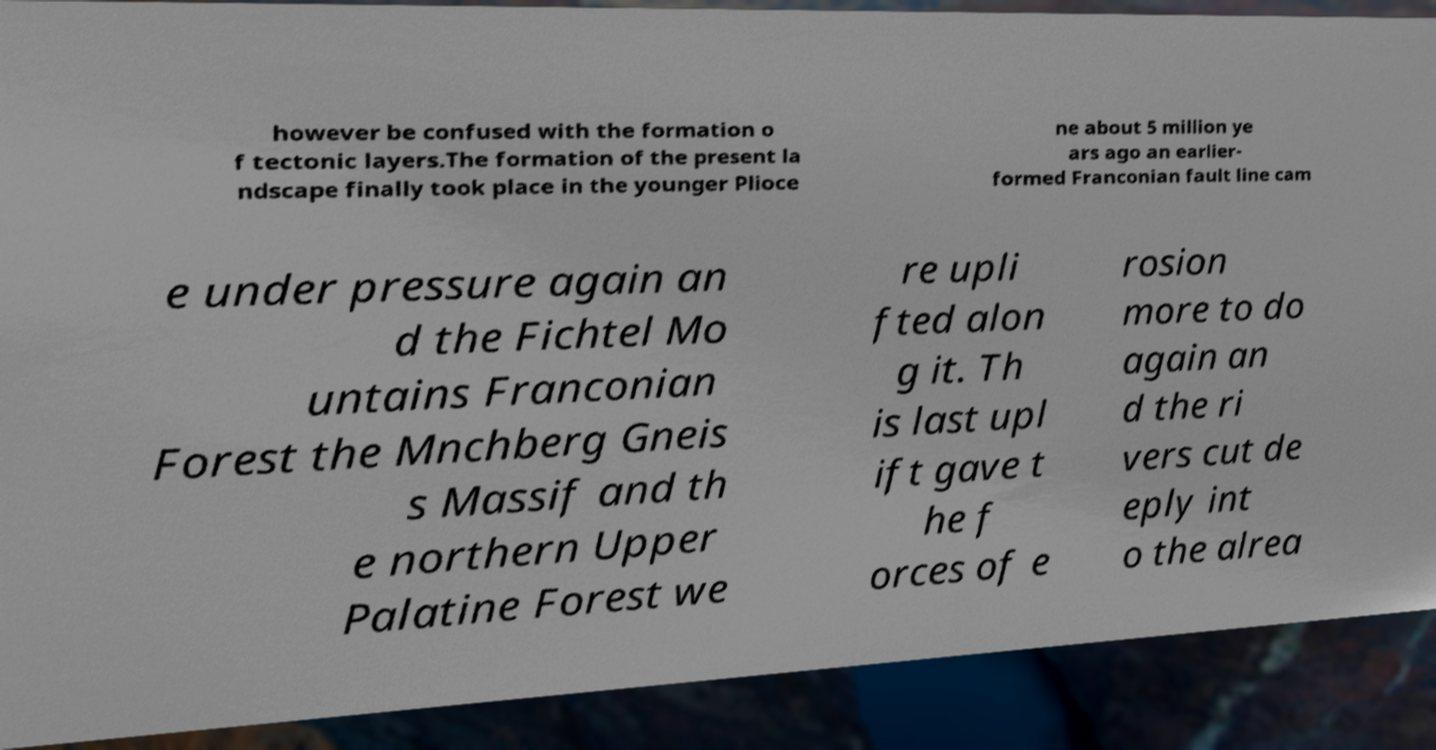Please identify and transcribe the text found in this image. however be confused with the formation o f tectonic layers.The formation of the present la ndscape finally took place in the younger Plioce ne about 5 million ye ars ago an earlier- formed Franconian fault line cam e under pressure again an d the Fichtel Mo untains Franconian Forest the Mnchberg Gneis s Massif and th e northern Upper Palatine Forest we re upli fted alon g it. Th is last upl ift gave t he f orces of e rosion more to do again an d the ri vers cut de eply int o the alrea 